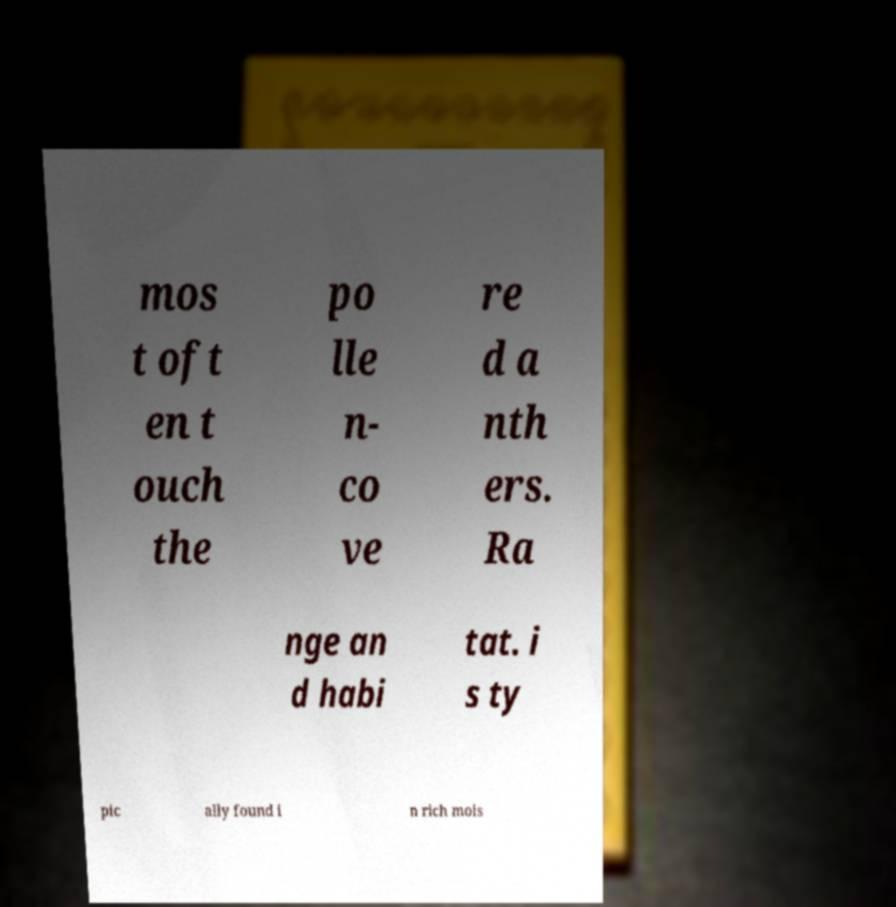There's text embedded in this image that I need extracted. Can you transcribe it verbatim? mos t oft en t ouch the po lle n- co ve re d a nth ers. Ra nge an d habi tat. i s ty pic ally found i n rich mois 